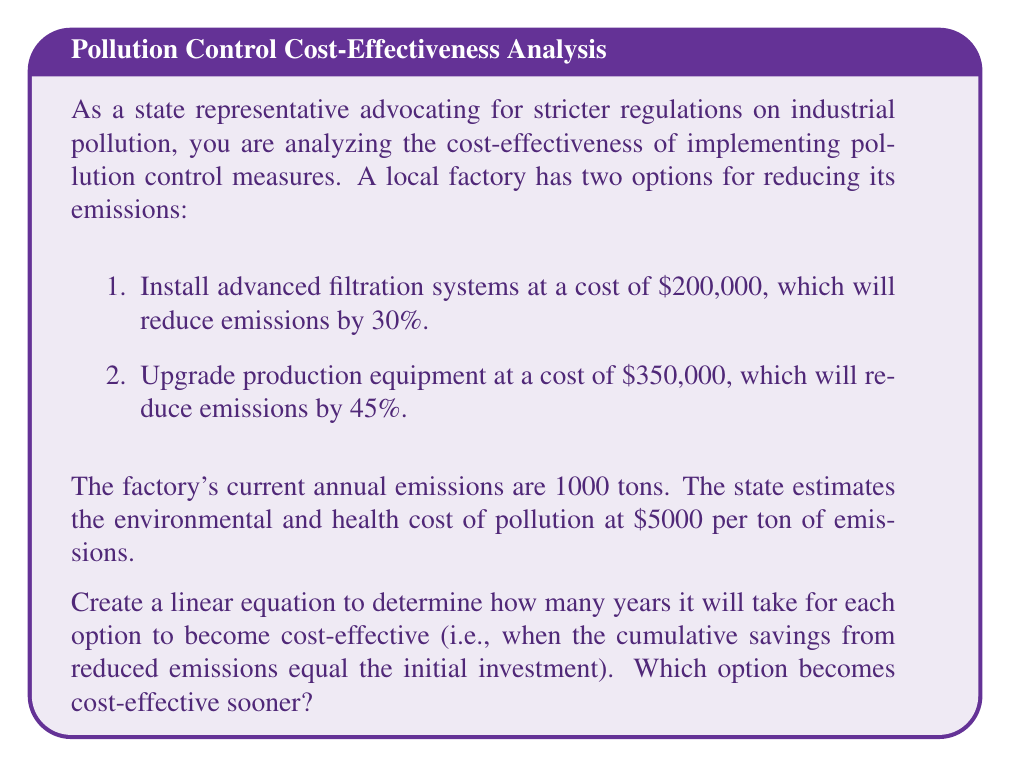What is the answer to this math problem? Let's approach this problem step-by-step:

1. Calculate the annual reduction in emissions for each option:
   Option 1: $1000 \times 0.30 = 300$ tons
   Option 2: $1000 \times 0.45 = 450$ tons

2. Calculate the annual savings from reduced emissions:
   Option 1: $300 \times \$5000 = \$1,500,000$
   Option 2: $450 \times \$5000 = \$2,250,000$

3. Set up linear equations for each option, where $x$ is the number of years:
   Option 1: $1,500,000x = 200,000$
   Option 2: $2,250,000x = 350,000$

4. Solve each equation for $x$:
   Option 1: $x = \frac{200,000}{1,500,000} = \frac{2}{15} = 0.1333$ years
   Option 2: $x = \frac{350,000}{2,250,000} = \frac{7}{45} = 0.1556$ years

5. Convert years to days:
   Option 1: $0.1333 \times 365 = 48.65$ days
   Option 2: $0.1556 \times 365 = 56.79$ days

Therefore, Option 1 becomes cost-effective sooner, after approximately 49 days, while Option 2 takes about 57 days to become cost-effective.
Answer: Option 1 (installing advanced filtration systems) becomes cost-effective sooner, after approximately 49 days, compared to Option 2 (upgrading production equipment) which takes about 57 days. 